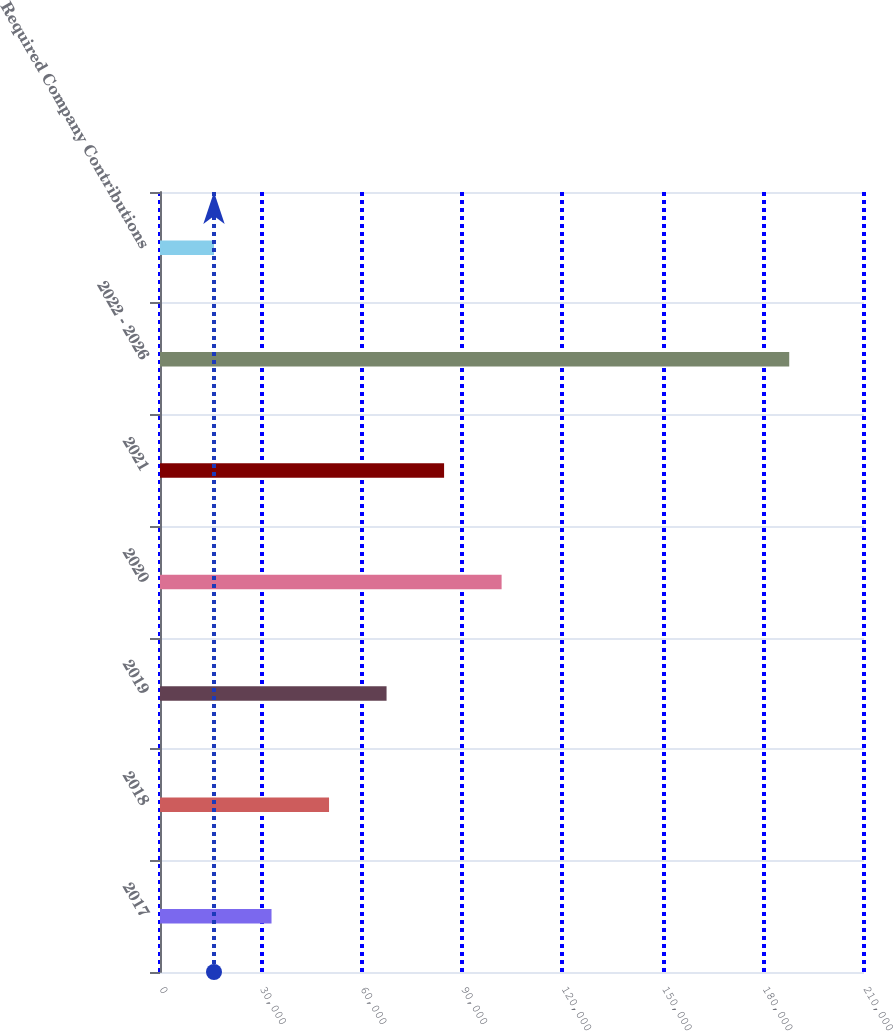<chart> <loc_0><loc_0><loc_500><loc_500><bar_chart><fcel>2017<fcel>2018<fcel>2019<fcel>2020<fcel>2021<fcel>2022 - 2026<fcel>Required Company Contributions<nl><fcel>33265.9<fcel>50424.8<fcel>67583.7<fcel>101902<fcel>84742.6<fcel>187696<fcel>16107<nl></chart> 